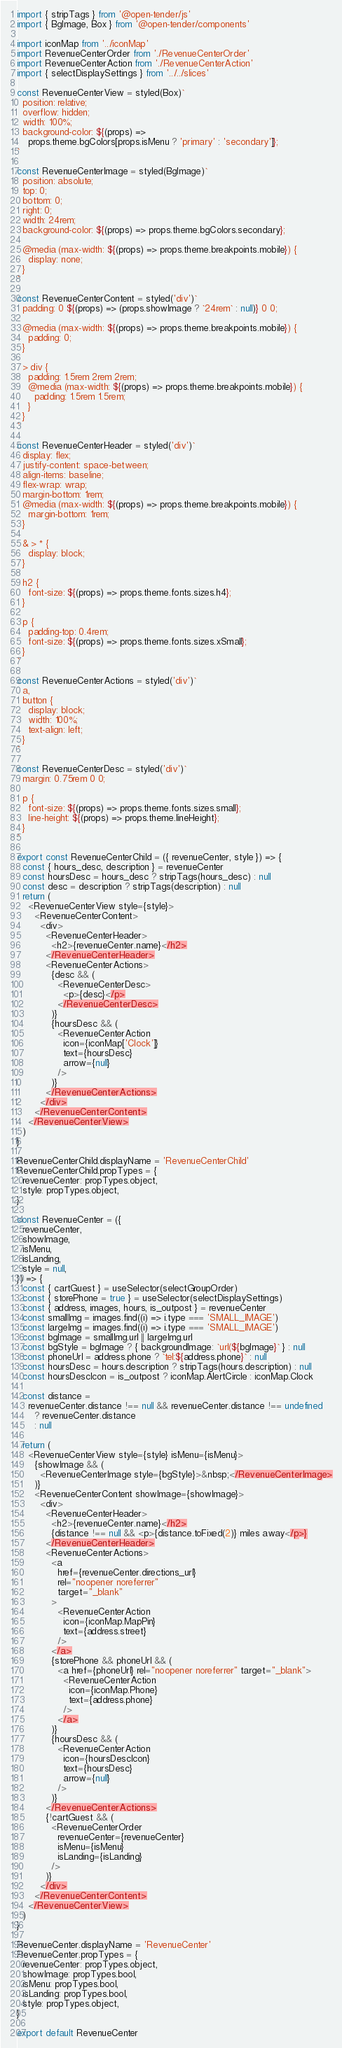Convert code to text. <code><loc_0><loc_0><loc_500><loc_500><_JavaScript_>import { stripTags } from '@open-tender/js'
import { BgImage, Box } from '@open-tender/components'

import iconMap from '../iconMap'
import RevenueCenterOrder from './RevenueCenterOrder'
import RevenueCenterAction from './RevenueCenterAction'
import { selectDisplaySettings } from '../../slices'

const RevenueCenterView = styled(Box)`
  position: relative;
  overflow: hidden;
  width: 100%;
  background-color: ${(props) =>
    props.theme.bgColors[props.isMenu ? 'primary' : 'secondary']};
`

const RevenueCenterImage = styled(BgImage)`
  position: absolute;
  top: 0;
  bottom: 0;
  right: 0;
  width: 24rem;
  background-color: ${(props) => props.theme.bgColors.secondary};

  @media (max-width: ${(props) => props.theme.breakpoints.mobile}) {
    display: none;
  }
`

const RevenueCenterContent = styled('div')`
  padding: 0 ${(props) => (props.showImage ? `24rem` : null)} 0 0;

  @media (max-width: ${(props) => props.theme.breakpoints.mobile}) {
    padding: 0;
  }

  > div {
    padding: 1.5rem 2rem 2rem;
    @media (max-width: ${(props) => props.theme.breakpoints.mobile}) {
      padding: 1.5rem 1.5rem;
    }
  }
`

const RevenueCenterHeader = styled('div')`
  display: flex;
  justify-content: space-between;
  align-items: baseline;
  flex-wrap: wrap;
  margin-bottom: 1rem;
  @media (max-width: ${(props) => props.theme.breakpoints.mobile}) {
    margin-bottom: 1rem;
  }

  & > * {
    display: block;
  }

  h2 {
    font-size: ${(props) => props.theme.fonts.sizes.h4};
  }

  p {
    padding-top: 0.4rem;
    font-size: ${(props) => props.theme.fonts.sizes.xSmall};
  }
`

const RevenueCenterActions = styled('div')`
  a,
  button {
    display: block;
    width: 100%;
    text-align: left;
  }
`

const RevenueCenterDesc = styled('div')`
  margin: 0.75rem 0 0;

  p {
    font-size: ${(props) => props.theme.fonts.sizes.small};
    line-height: ${(props) => props.theme.lineHeight};
  }
`

export const RevenueCenterChild = ({ revenueCenter, style }) => {
  const { hours_desc, description } = revenueCenter
  const hoursDesc = hours_desc ? stripTags(hours_desc) : null
  const desc = description ? stripTags(description) : null
  return (
    <RevenueCenterView style={style}>
      <RevenueCenterContent>
        <div>
          <RevenueCenterHeader>
            <h2>{revenueCenter.name}</h2>
          </RevenueCenterHeader>
          <RevenueCenterActions>
            {desc && (
              <RevenueCenterDesc>
                <p>{desc}</p>
              </RevenueCenterDesc>
            )}
            {hoursDesc && (
              <RevenueCenterAction
                icon={iconMap['Clock']}
                text={hoursDesc}
                arrow={null}
              />
            )}
          </RevenueCenterActions>
        </div>
      </RevenueCenterContent>
    </RevenueCenterView>
  )
}

RevenueCenterChild.displayName = 'RevenueCenterChild'
RevenueCenterChild.propTypes = {
  revenueCenter: propTypes.object,
  style: propTypes.object,
}

const RevenueCenter = ({
  revenueCenter,
  showImage,
  isMenu,
  isLanding,
  style = null,
}) => {
  const { cartGuest } = useSelector(selectGroupOrder)
  const { storePhone = true } = useSelector(selectDisplaySettings)
  const { address, images, hours, is_outpost } = revenueCenter
  const smallImg = images.find((i) => i.type === 'SMALL_IMAGE')
  const largeImg = images.find((i) => i.type === 'SMALL_IMAGE')
  const bgImage = smallImg.url || largeImg.url
  const bgStyle = bgImage ? { backgroundImage: `url(${bgImage}` } : null
  const phoneUrl = address.phone ? `tel:${address.phone}` : null
  const hoursDesc = hours.description ? stripTags(hours.description) : null
  const hoursDescIcon = is_outpost ? iconMap.AlertCircle : iconMap.Clock

  const distance =
    revenueCenter.distance !== null && revenueCenter.distance !== undefined
      ? revenueCenter.distance
      : null

  return (
    <RevenueCenterView style={style} isMenu={isMenu}>
      {showImage && (
        <RevenueCenterImage style={bgStyle}>&nbsp;</RevenueCenterImage>
      )}
      <RevenueCenterContent showImage={showImage}>
        <div>
          <RevenueCenterHeader>
            <h2>{revenueCenter.name}</h2>
            {distance !== null && <p>{distance.toFixed(2)} miles away</p>}
          </RevenueCenterHeader>
          <RevenueCenterActions>
            <a
              href={revenueCenter.directions_url}
              rel="noopener noreferrer"
              target="_blank"
            >
              <RevenueCenterAction
                icon={iconMap.MapPin}
                text={address.street}
              />
            </a>
            {storePhone && phoneUrl && (
              <a href={phoneUrl} rel="noopener noreferrer" target="_blank">
                <RevenueCenterAction
                  icon={iconMap.Phone}
                  text={address.phone}
                />
              </a>
            )}
            {hoursDesc && (
              <RevenueCenterAction
                icon={hoursDescIcon}
                text={hoursDesc}
                arrow={null}
              />
            )}
          </RevenueCenterActions>
          {!cartGuest && (
            <RevenueCenterOrder
              revenueCenter={revenueCenter}
              isMenu={isMenu}
              isLanding={isLanding}
            />
          )}
        </div>
      </RevenueCenterContent>
    </RevenueCenterView>
  )
}

RevenueCenter.displayName = 'RevenueCenter'
RevenueCenter.propTypes = {
  revenueCenter: propTypes.object,
  showImage: propTypes.bool,
  isMenu: propTypes.bool,
  isLanding: propTypes.bool,
  style: propTypes.object,
}

export default RevenueCenter
</code> 